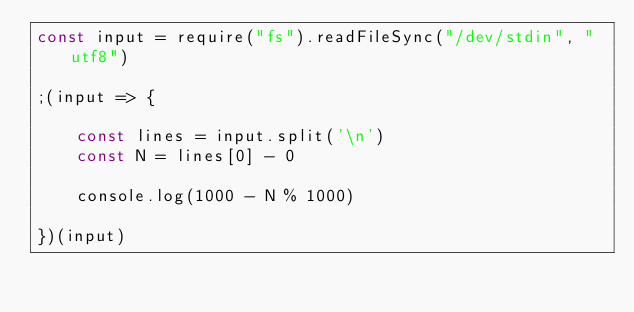Convert code to text. <code><loc_0><loc_0><loc_500><loc_500><_JavaScript_>const input = require("fs").readFileSync("/dev/stdin", "utf8")

;(input => {

    const lines = input.split('\n')
    const N = lines[0] - 0

    console.log(1000 - N % 1000)

})(input)
</code> 